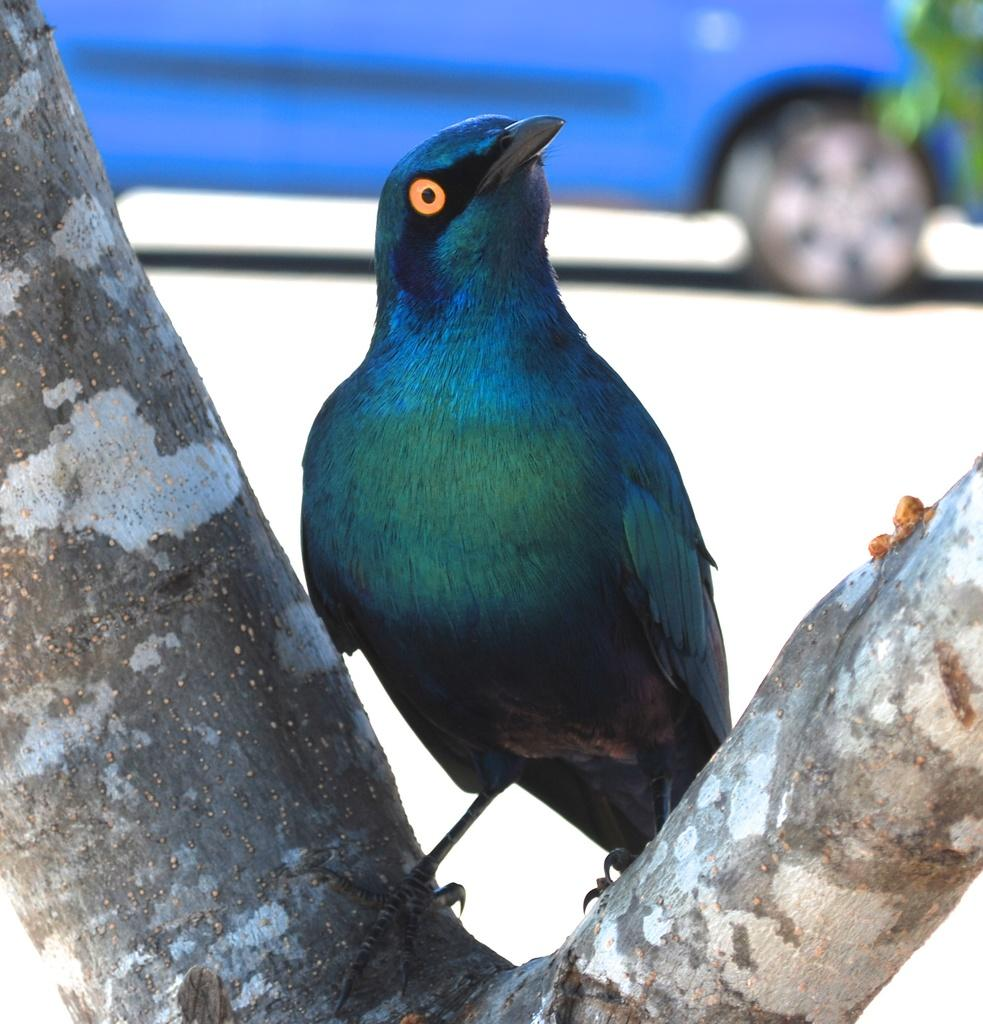What is on the tree in the image? There is a bird on the basking on the barks of a tree in the image. What type of vehicle can be seen in the background of the image? There is a blue color car in the background of the image. Where is the car located in the image? The car is on the road in the image. What type of vegetation is visible in the image? Leaves are visible in the image. What type of drug can be seen in the image? There is no drug present in the image. The image features a bird on a tree and a blue car on the road, with leaves visible in the background. 